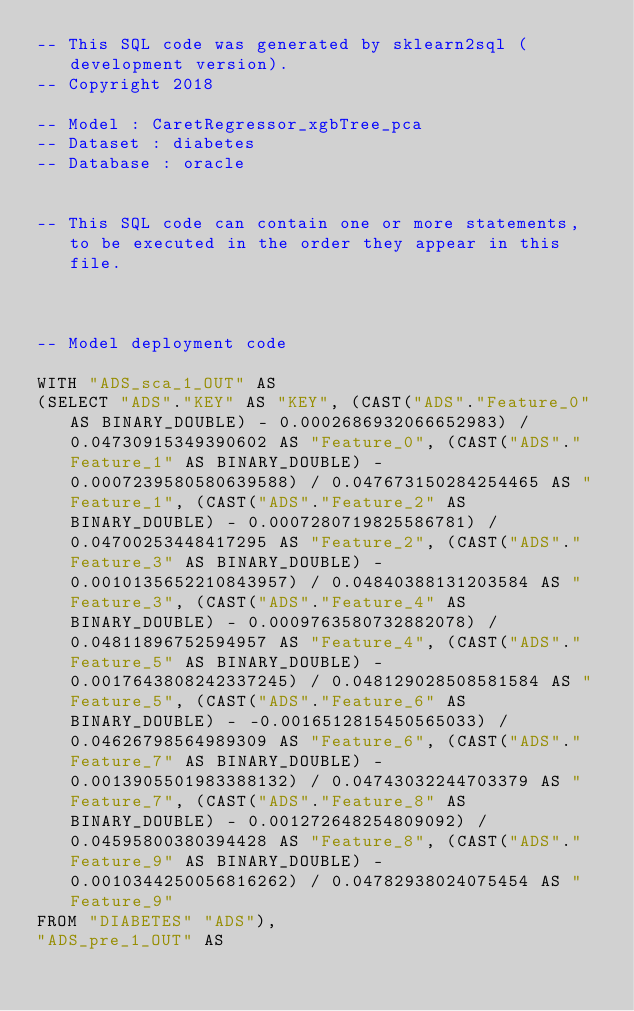<code> <loc_0><loc_0><loc_500><loc_500><_SQL_>-- This SQL code was generated by sklearn2sql (development version).
-- Copyright 2018

-- Model : CaretRegressor_xgbTree_pca
-- Dataset : diabetes
-- Database : oracle


-- This SQL code can contain one or more statements, to be executed in the order they appear in this file.



-- Model deployment code

WITH "ADS_sca_1_OUT" AS 
(SELECT "ADS"."KEY" AS "KEY", (CAST("ADS"."Feature_0" AS BINARY_DOUBLE) - 0.0002686932066652983) / 0.04730915349390602 AS "Feature_0", (CAST("ADS"."Feature_1" AS BINARY_DOUBLE) - 0.0007239580580639588) / 0.047673150284254465 AS "Feature_1", (CAST("ADS"."Feature_2" AS BINARY_DOUBLE) - 0.0007280719825586781) / 0.04700253448417295 AS "Feature_2", (CAST("ADS"."Feature_3" AS BINARY_DOUBLE) - 0.0010135652210843957) / 0.04840388131203584 AS "Feature_3", (CAST("ADS"."Feature_4" AS BINARY_DOUBLE) - 0.0009763580732882078) / 0.04811896752594957 AS "Feature_4", (CAST("ADS"."Feature_5" AS BINARY_DOUBLE) - 0.0017643808242337245) / 0.048129028508581584 AS "Feature_5", (CAST("ADS"."Feature_6" AS BINARY_DOUBLE) - -0.0016512815450565033) / 0.04626798564989309 AS "Feature_6", (CAST("ADS"."Feature_7" AS BINARY_DOUBLE) - 0.0013905501983388132) / 0.04743032244703379 AS "Feature_7", (CAST("ADS"."Feature_8" AS BINARY_DOUBLE) - 0.001272648254809092) / 0.04595800380394428 AS "Feature_8", (CAST("ADS"."Feature_9" AS BINARY_DOUBLE) - 0.0010344250056816262) / 0.04782938024075454 AS "Feature_9" 
FROM "DIABETES" "ADS"), 
"ADS_pre_1_OUT" AS </code> 